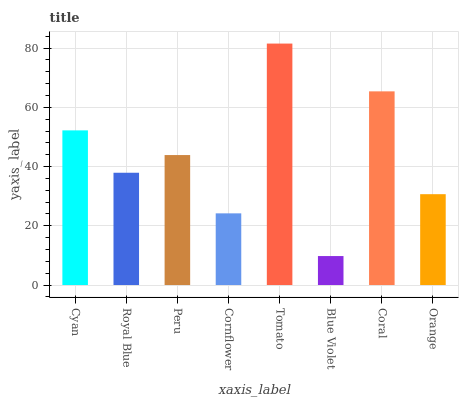Is Blue Violet the minimum?
Answer yes or no. Yes. Is Tomato the maximum?
Answer yes or no. Yes. Is Royal Blue the minimum?
Answer yes or no. No. Is Royal Blue the maximum?
Answer yes or no. No. Is Cyan greater than Royal Blue?
Answer yes or no. Yes. Is Royal Blue less than Cyan?
Answer yes or no. Yes. Is Royal Blue greater than Cyan?
Answer yes or no. No. Is Cyan less than Royal Blue?
Answer yes or no. No. Is Peru the high median?
Answer yes or no. Yes. Is Royal Blue the low median?
Answer yes or no. Yes. Is Coral the high median?
Answer yes or no. No. Is Coral the low median?
Answer yes or no. No. 